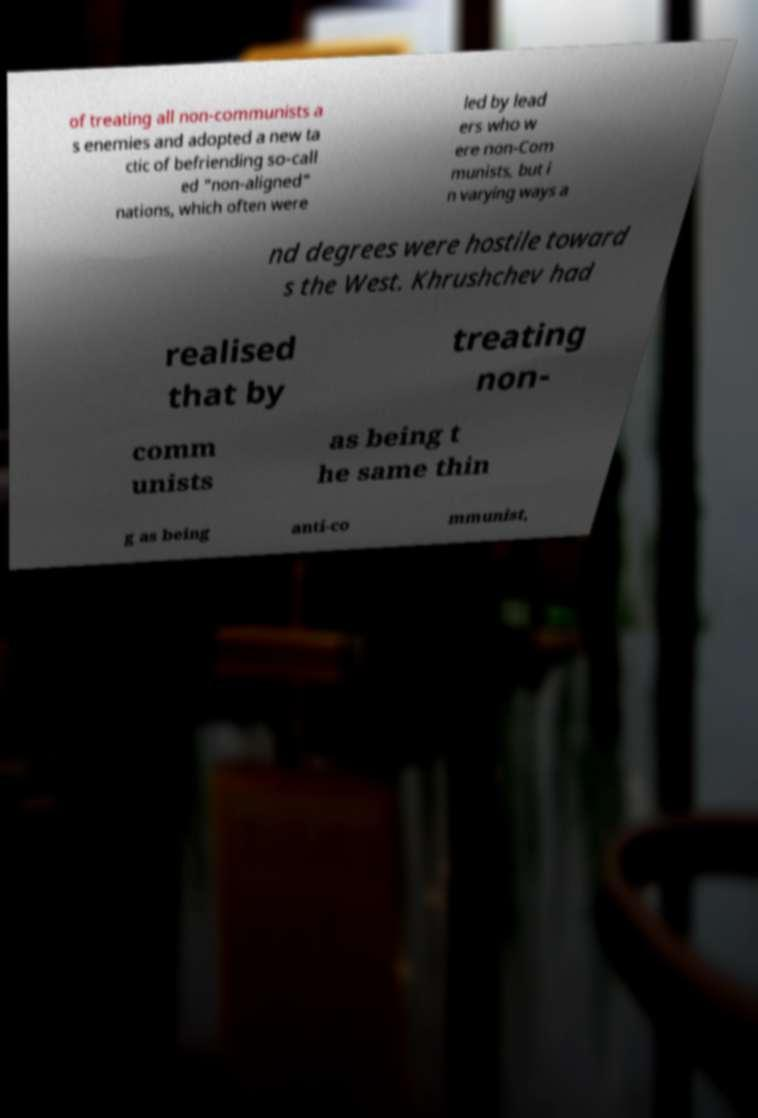Could you assist in decoding the text presented in this image and type it out clearly? of treating all non-communists a s enemies and adopted a new ta ctic of befriending so-call ed "non-aligned" nations, which often were led by lead ers who w ere non-Com munists, but i n varying ways a nd degrees were hostile toward s the West. Khrushchev had realised that by treating non- comm unists as being t he same thin g as being anti-co mmunist, 